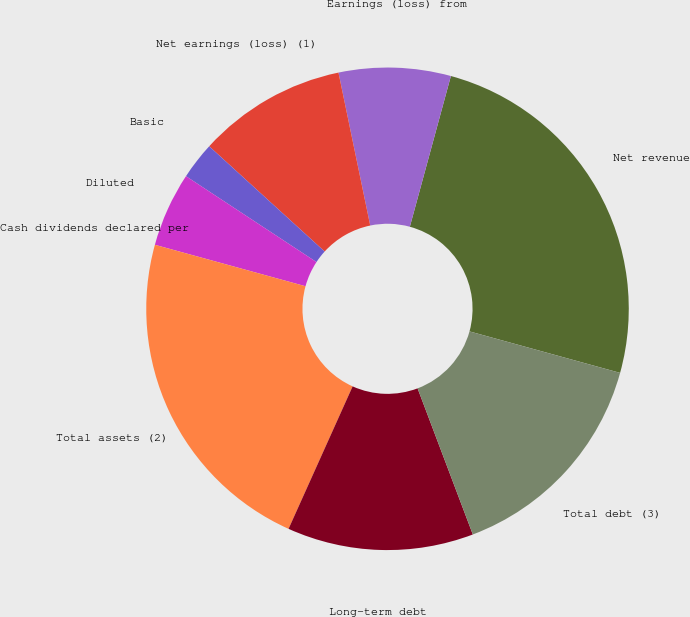Convert chart. <chart><loc_0><loc_0><loc_500><loc_500><pie_chart><fcel>Net revenue<fcel>Earnings (loss) from<fcel>Net earnings (loss) (1)<fcel>Basic<fcel>Diluted<fcel>Cash dividends declared per<fcel>Total assets (2)<fcel>Long-term debt<fcel>Total debt (3)<nl><fcel>25.05%<fcel>7.49%<fcel>9.98%<fcel>2.5%<fcel>4.99%<fcel>0.0%<fcel>22.55%<fcel>12.48%<fcel>14.97%<nl></chart> 